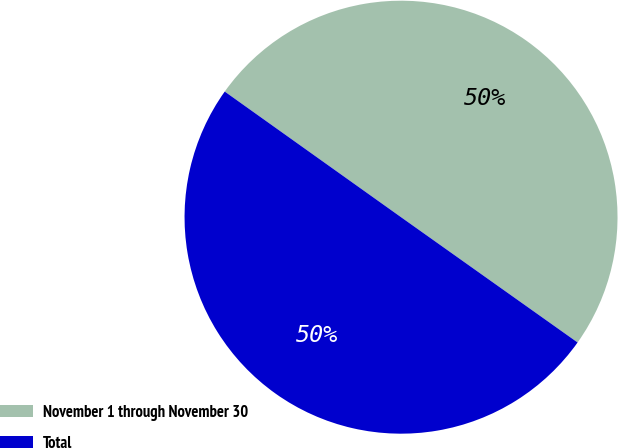Convert chart. <chart><loc_0><loc_0><loc_500><loc_500><pie_chart><fcel>November 1 through November 30<fcel>Total<nl><fcel>49.97%<fcel>50.03%<nl></chart> 